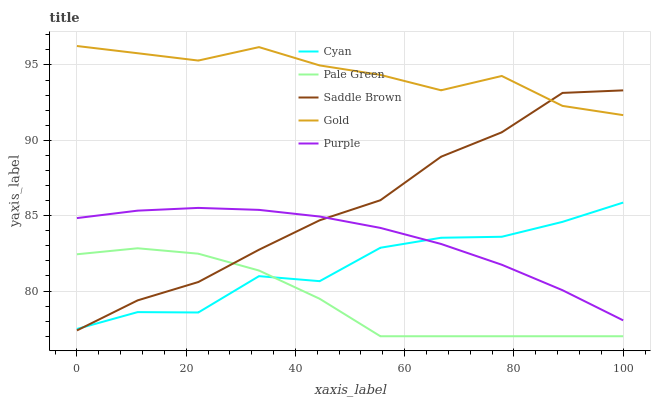Does Pale Green have the minimum area under the curve?
Answer yes or no. Yes. Does Gold have the maximum area under the curve?
Answer yes or no. Yes. Does Cyan have the minimum area under the curve?
Answer yes or no. No. Does Cyan have the maximum area under the curve?
Answer yes or no. No. Is Purple the smoothest?
Answer yes or no. Yes. Is Cyan the roughest?
Answer yes or no. Yes. Is Pale Green the smoothest?
Answer yes or no. No. Is Pale Green the roughest?
Answer yes or no. No. Does Pale Green have the lowest value?
Answer yes or no. Yes. Does Cyan have the lowest value?
Answer yes or no. No. Does Gold have the highest value?
Answer yes or no. Yes. Does Cyan have the highest value?
Answer yes or no. No. Is Pale Green less than Purple?
Answer yes or no. Yes. Is Purple greater than Pale Green?
Answer yes or no. Yes. Does Saddle Brown intersect Cyan?
Answer yes or no. Yes. Is Saddle Brown less than Cyan?
Answer yes or no. No. Is Saddle Brown greater than Cyan?
Answer yes or no. No. Does Pale Green intersect Purple?
Answer yes or no. No. 